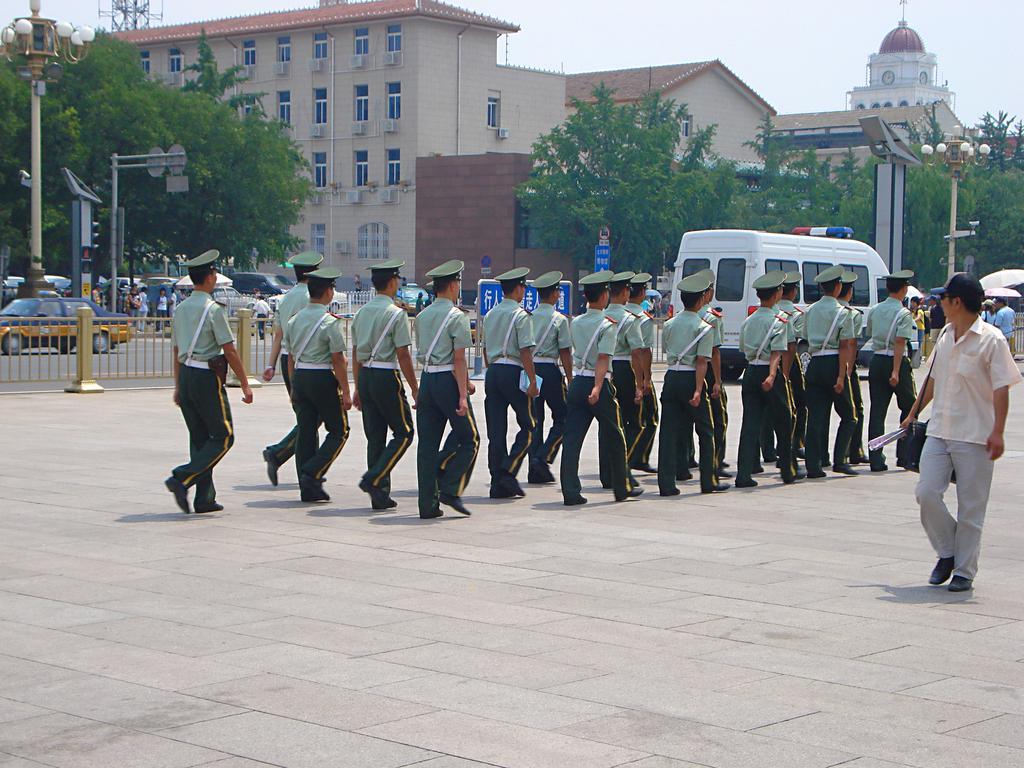Could you give a brief overview of what you see in this image? This is an outside view. Here I can see few men wearing uniforms, caps on the heads and marching on the ground. On the right side there is a man is walking by looking at these people. On the left side, I can see few vehicles on the road and also there is a railing. In the background, I can see few trees, poles and buildings. At the top of the image I can see the sky. 